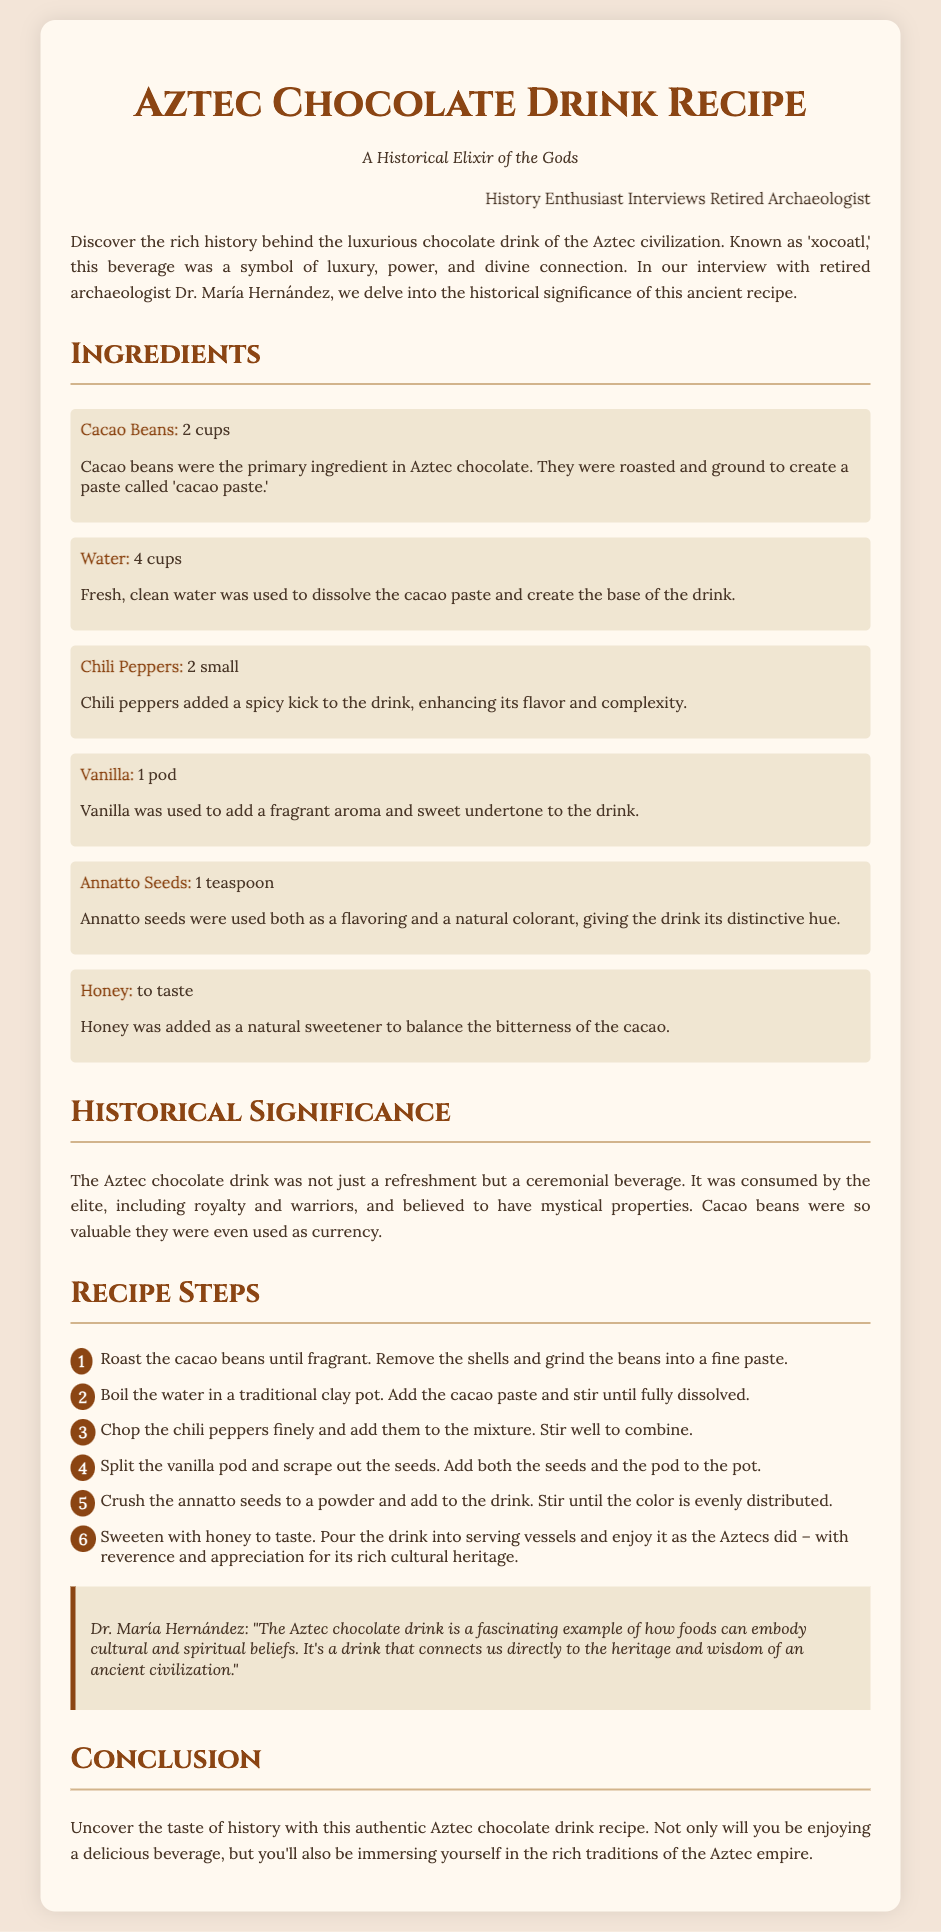What is the main ingredient used in the Aztec chocolate drink? The primary ingredient is mentioned in the ingredient list, highlighting cacao beans as essential for the drink.
Answer: Cacao Beans How many cups of water are needed for the recipe? The document specifies that 4 cups of water are required to dissolve the cacao paste.
Answer: 4 cups What was the ceremonial significance of the Aztec chocolate drink? The historical significance section explains that the drink was consumed by the elite and held mystical properties.
Answer: Ceremonial beverage Who is quoted in the document discussing the cultural implications of the drink? The interview quote section attributes insights about the drink to Dr. María Hernández.
Answer: Dr. María Hernández How many steps are there in the recipe? The recipe steps are enumerated, making it easy to count the total.
Answer: 6 steps What flavoring is added alongside cacao in the recipe? The list of ingredients includes vanilla as a key flavor component in the chocolate drink.
Answer: Vanilla What natural sweetener is suggested in the recipe? The ingredients detail that honey is used as a natural sweetener in the drink.
Answer: Honey What is the significance of cacao beans in the Aztec culture, according to the document? The historical significance section describes the immense value of cacao beans, even stating they were used as currency.
Answer: Currency 